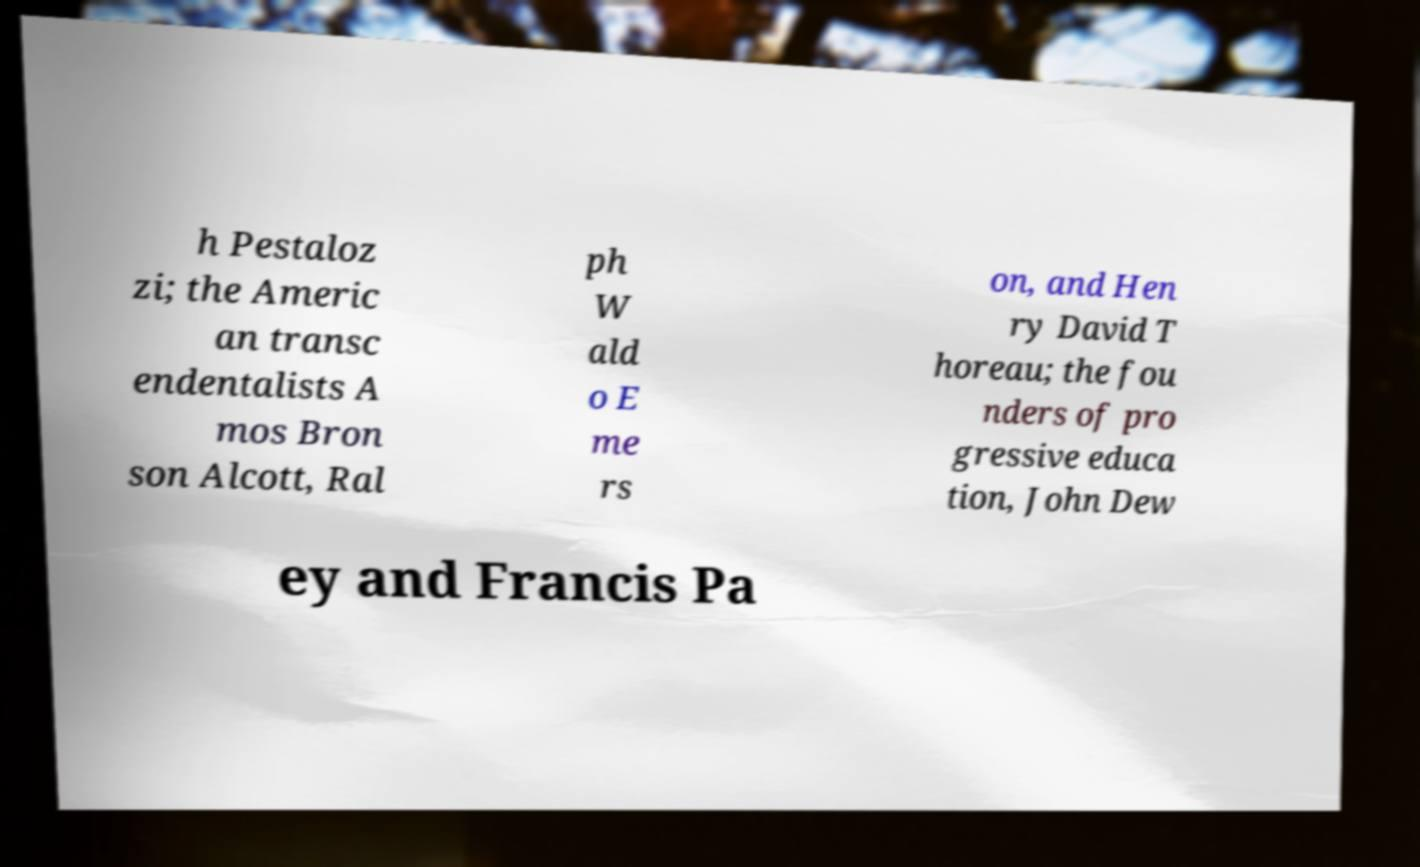Please read and relay the text visible in this image. What does it say? h Pestaloz zi; the Americ an transc endentalists A mos Bron son Alcott, Ral ph W ald o E me rs on, and Hen ry David T horeau; the fou nders of pro gressive educa tion, John Dew ey and Francis Pa 